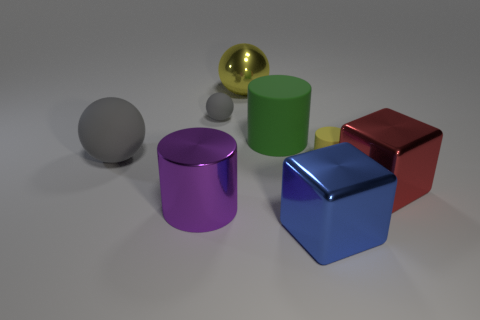What number of red things are either cubes or big rubber objects?
Your response must be concise. 1. There is a red thing in front of the yellow thing that is behind the large green rubber object; how big is it?
Provide a short and direct response. Large. What is the material of the green object that is the same shape as the tiny yellow object?
Your response must be concise. Rubber. How many matte cylinders have the same size as the purple metal cylinder?
Provide a short and direct response. 1. Does the purple cylinder have the same size as the green cylinder?
Keep it short and to the point. Yes. There is a metal thing that is on the right side of the yellow sphere and behind the purple cylinder; what size is it?
Your answer should be very brief. Large. Is the number of purple things that are to the right of the big red metal block greater than the number of red objects that are left of the tiny gray sphere?
Make the answer very short. No. There is a tiny object that is the same shape as the large green object; what color is it?
Offer a terse response. Yellow. There is a small matte thing right of the blue shiny block; is its color the same as the metal sphere?
Your answer should be compact. Yes. What number of large yellow things are there?
Provide a succinct answer. 1. 